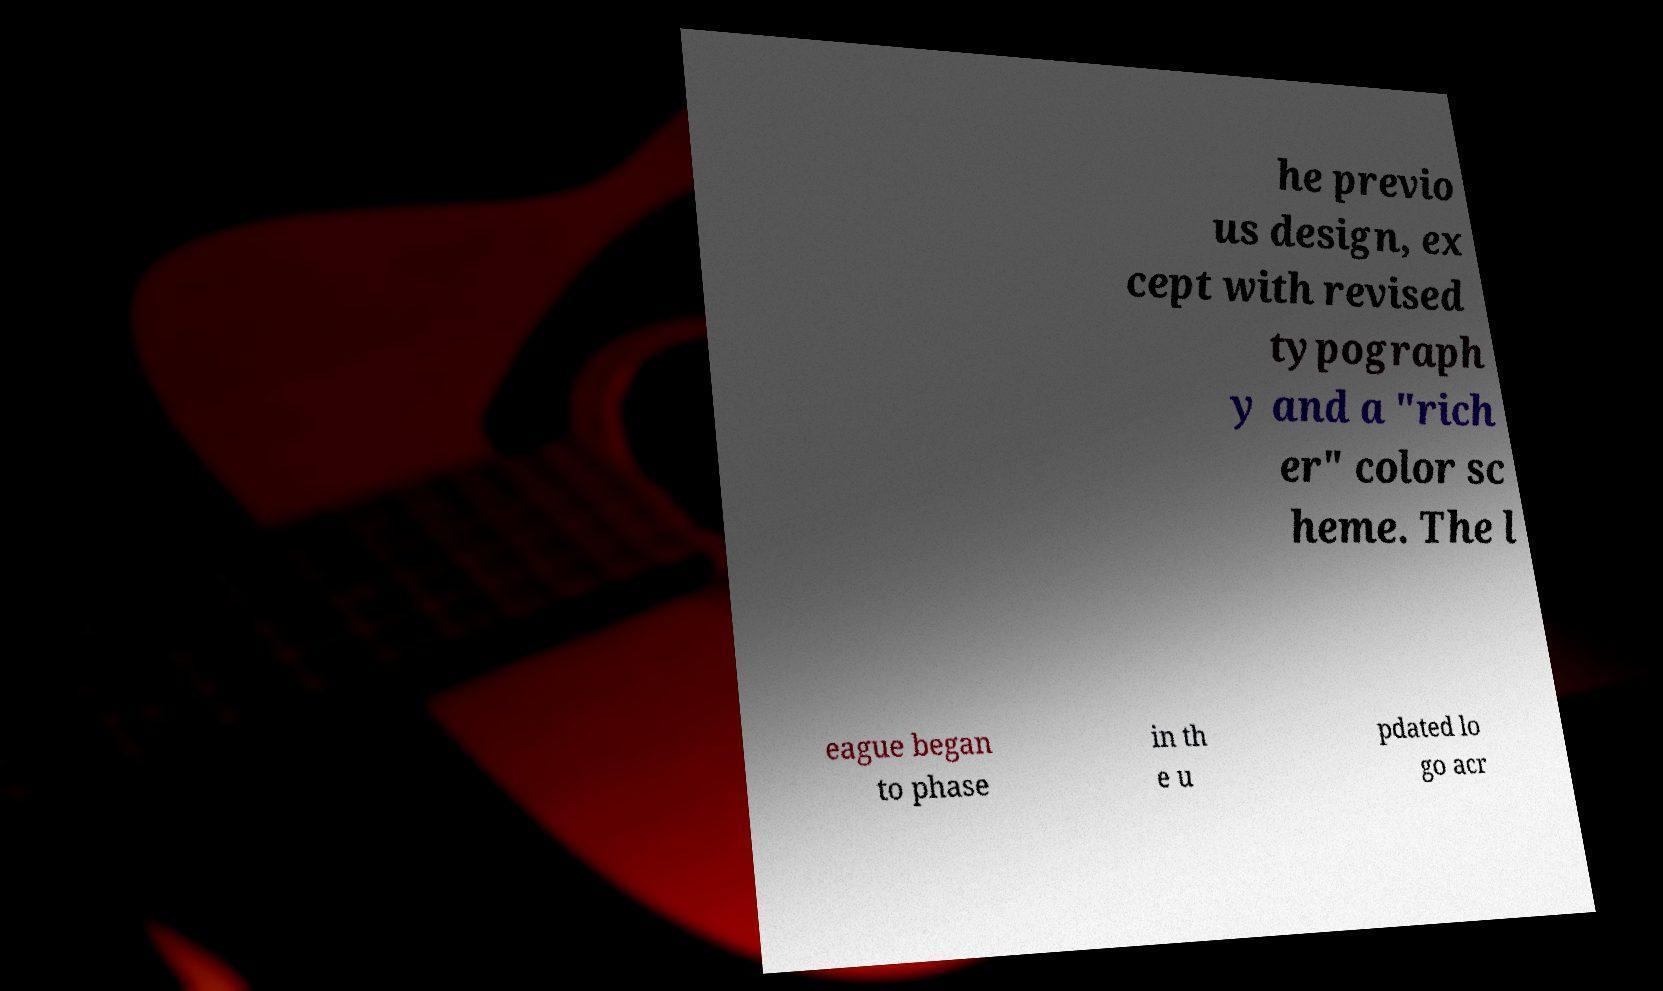For documentation purposes, I need the text within this image transcribed. Could you provide that? he previo us design, ex cept with revised typograph y and a "rich er" color sc heme. The l eague began to phase in th e u pdated lo go acr 